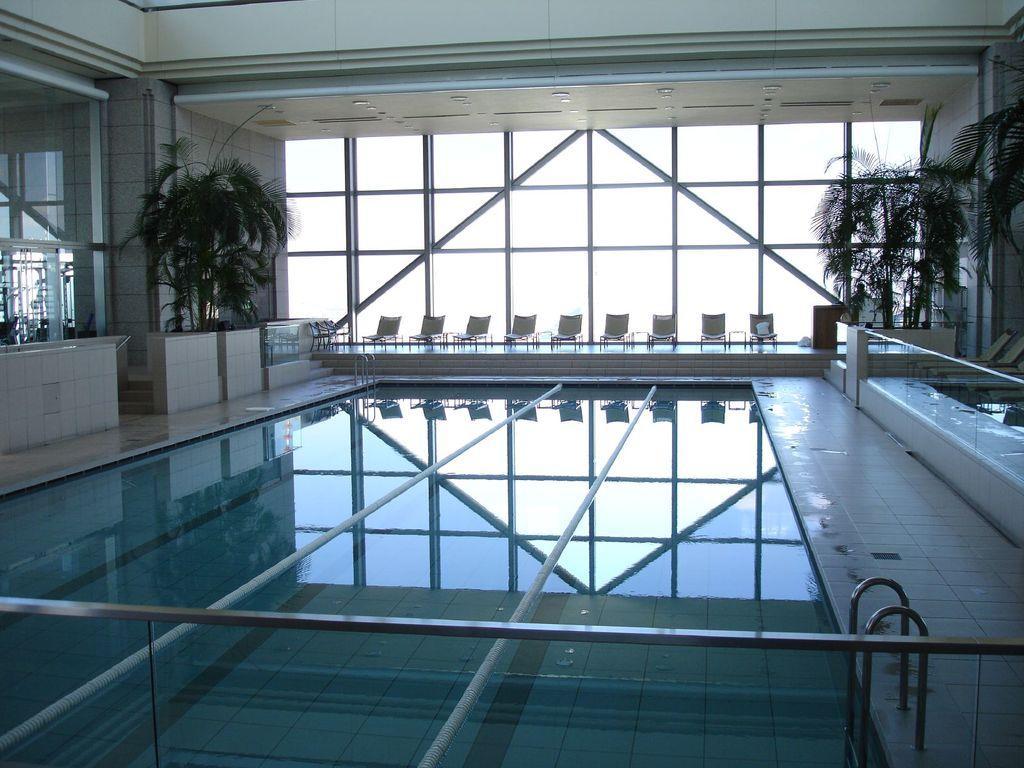Please provide a concise description of this image. In the center of the image we can see water. On the right side of the image we can see plants and chairs. On the left side of the image we can see glass windows and plants. In the background we can see chairs, glass windows and sky. 